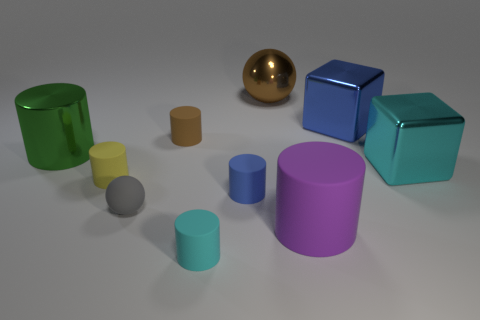Subtract 2 cylinders. How many cylinders are left? 4 Subtract all big metal cylinders. How many cylinders are left? 5 Subtract all purple cylinders. How many cylinders are left? 5 Subtract all cyan cylinders. Subtract all blue cubes. How many cylinders are left? 5 Subtract all spheres. How many objects are left? 8 Add 8 brown metal balls. How many brown metal balls exist? 9 Subtract 0 yellow blocks. How many objects are left? 10 Subtract all metal objects. Subtract all tiny matte cylinders. How many objects are left? 2 Add 8 small gray rubber things. How many small gray rubber things are left? 9 